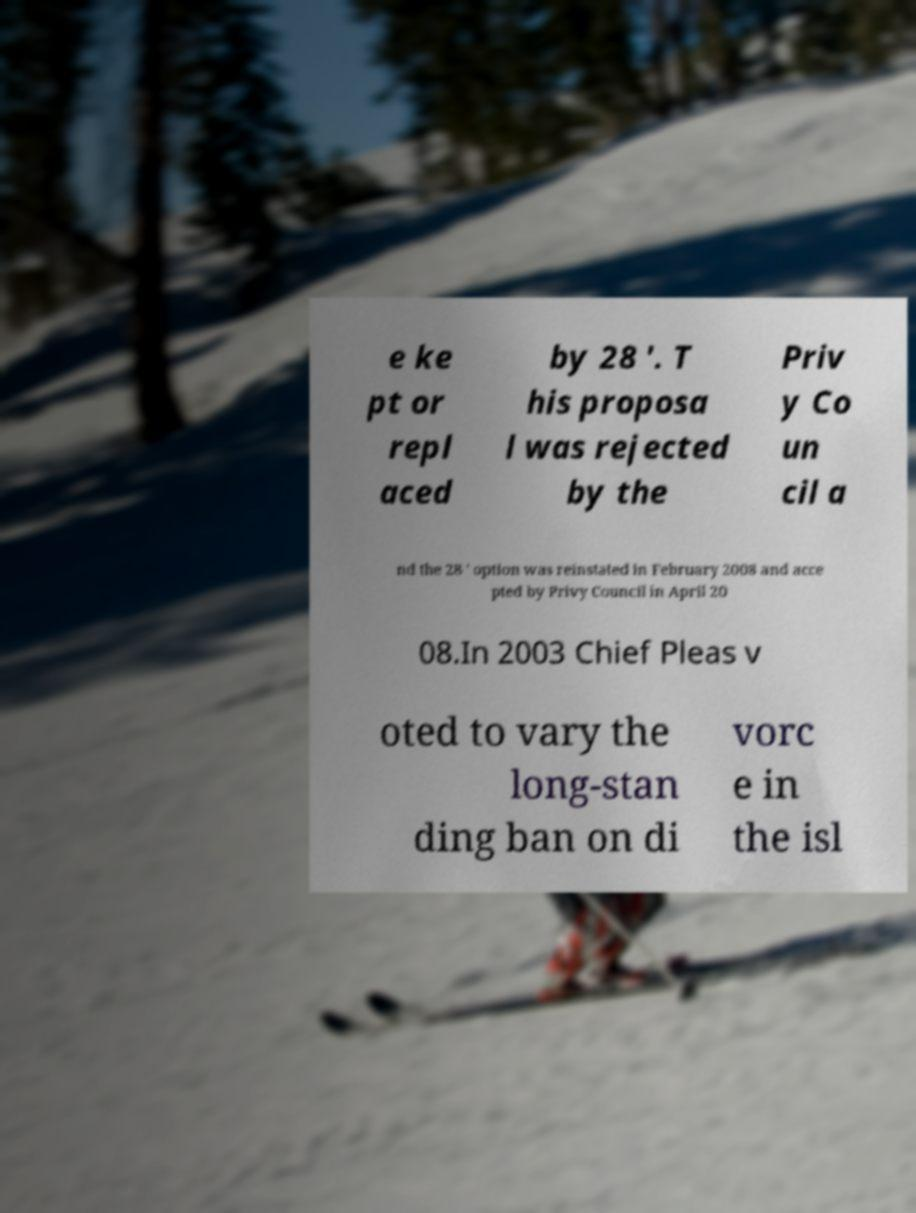Can you accurately transcribe the text from the provided image for me? e ke pt or repl aced by 28 '. T his proposa l was rejected by the Priv y Co un cil a nd the 28 ' option was reinstated in February 2008 and acce pted by Privy Council in April 20 08.In 2003 Chief Pleas v oted to vary the long-stan ding ban on di vorc e in the isl 